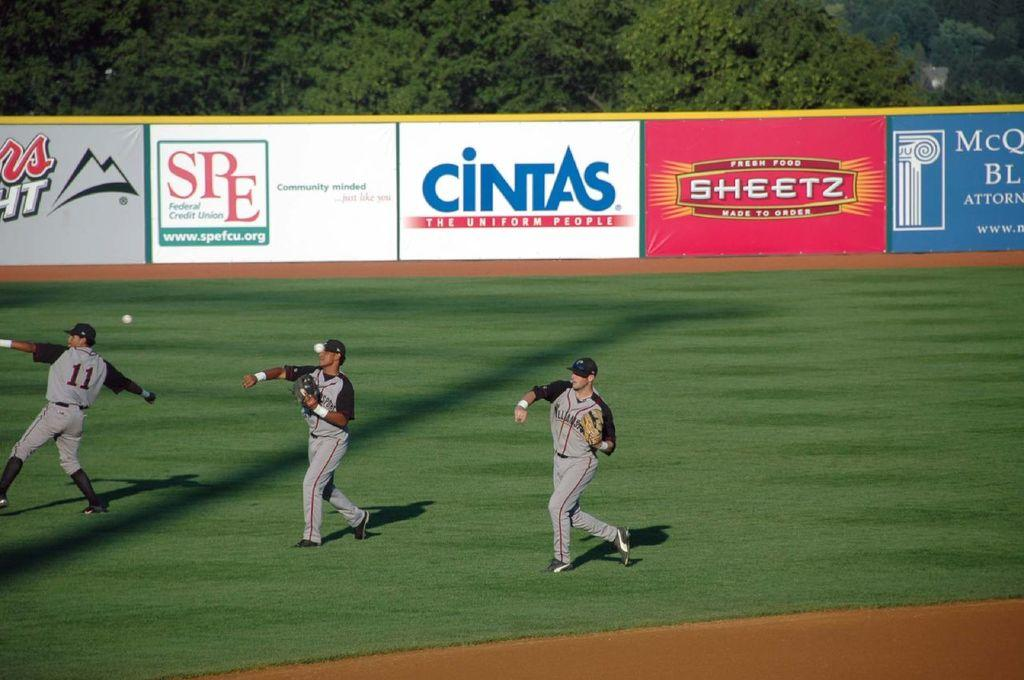<image>
Relay a brief, clear account of the picture shown. Three baseball players on a field with an ad that says CINTAS. 